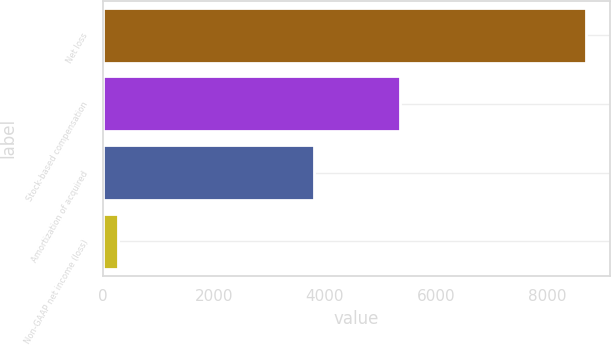<chart> <loc_0><loc_0><loc_500><loc_500><bar_chart><fcel>Net loss<fcel>Stock-based compensation<fcel>Amortization of acquired<fcel>Non-GAAP net income (loss)<nl><fcel>8705<fcel>5346<fcel>3798<fcel>271<nl></chart> 